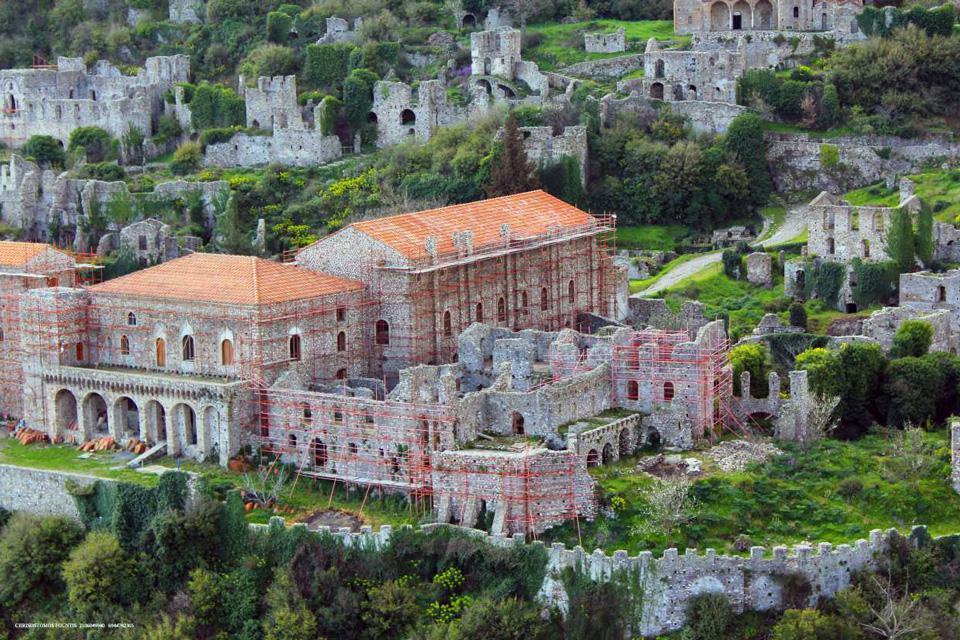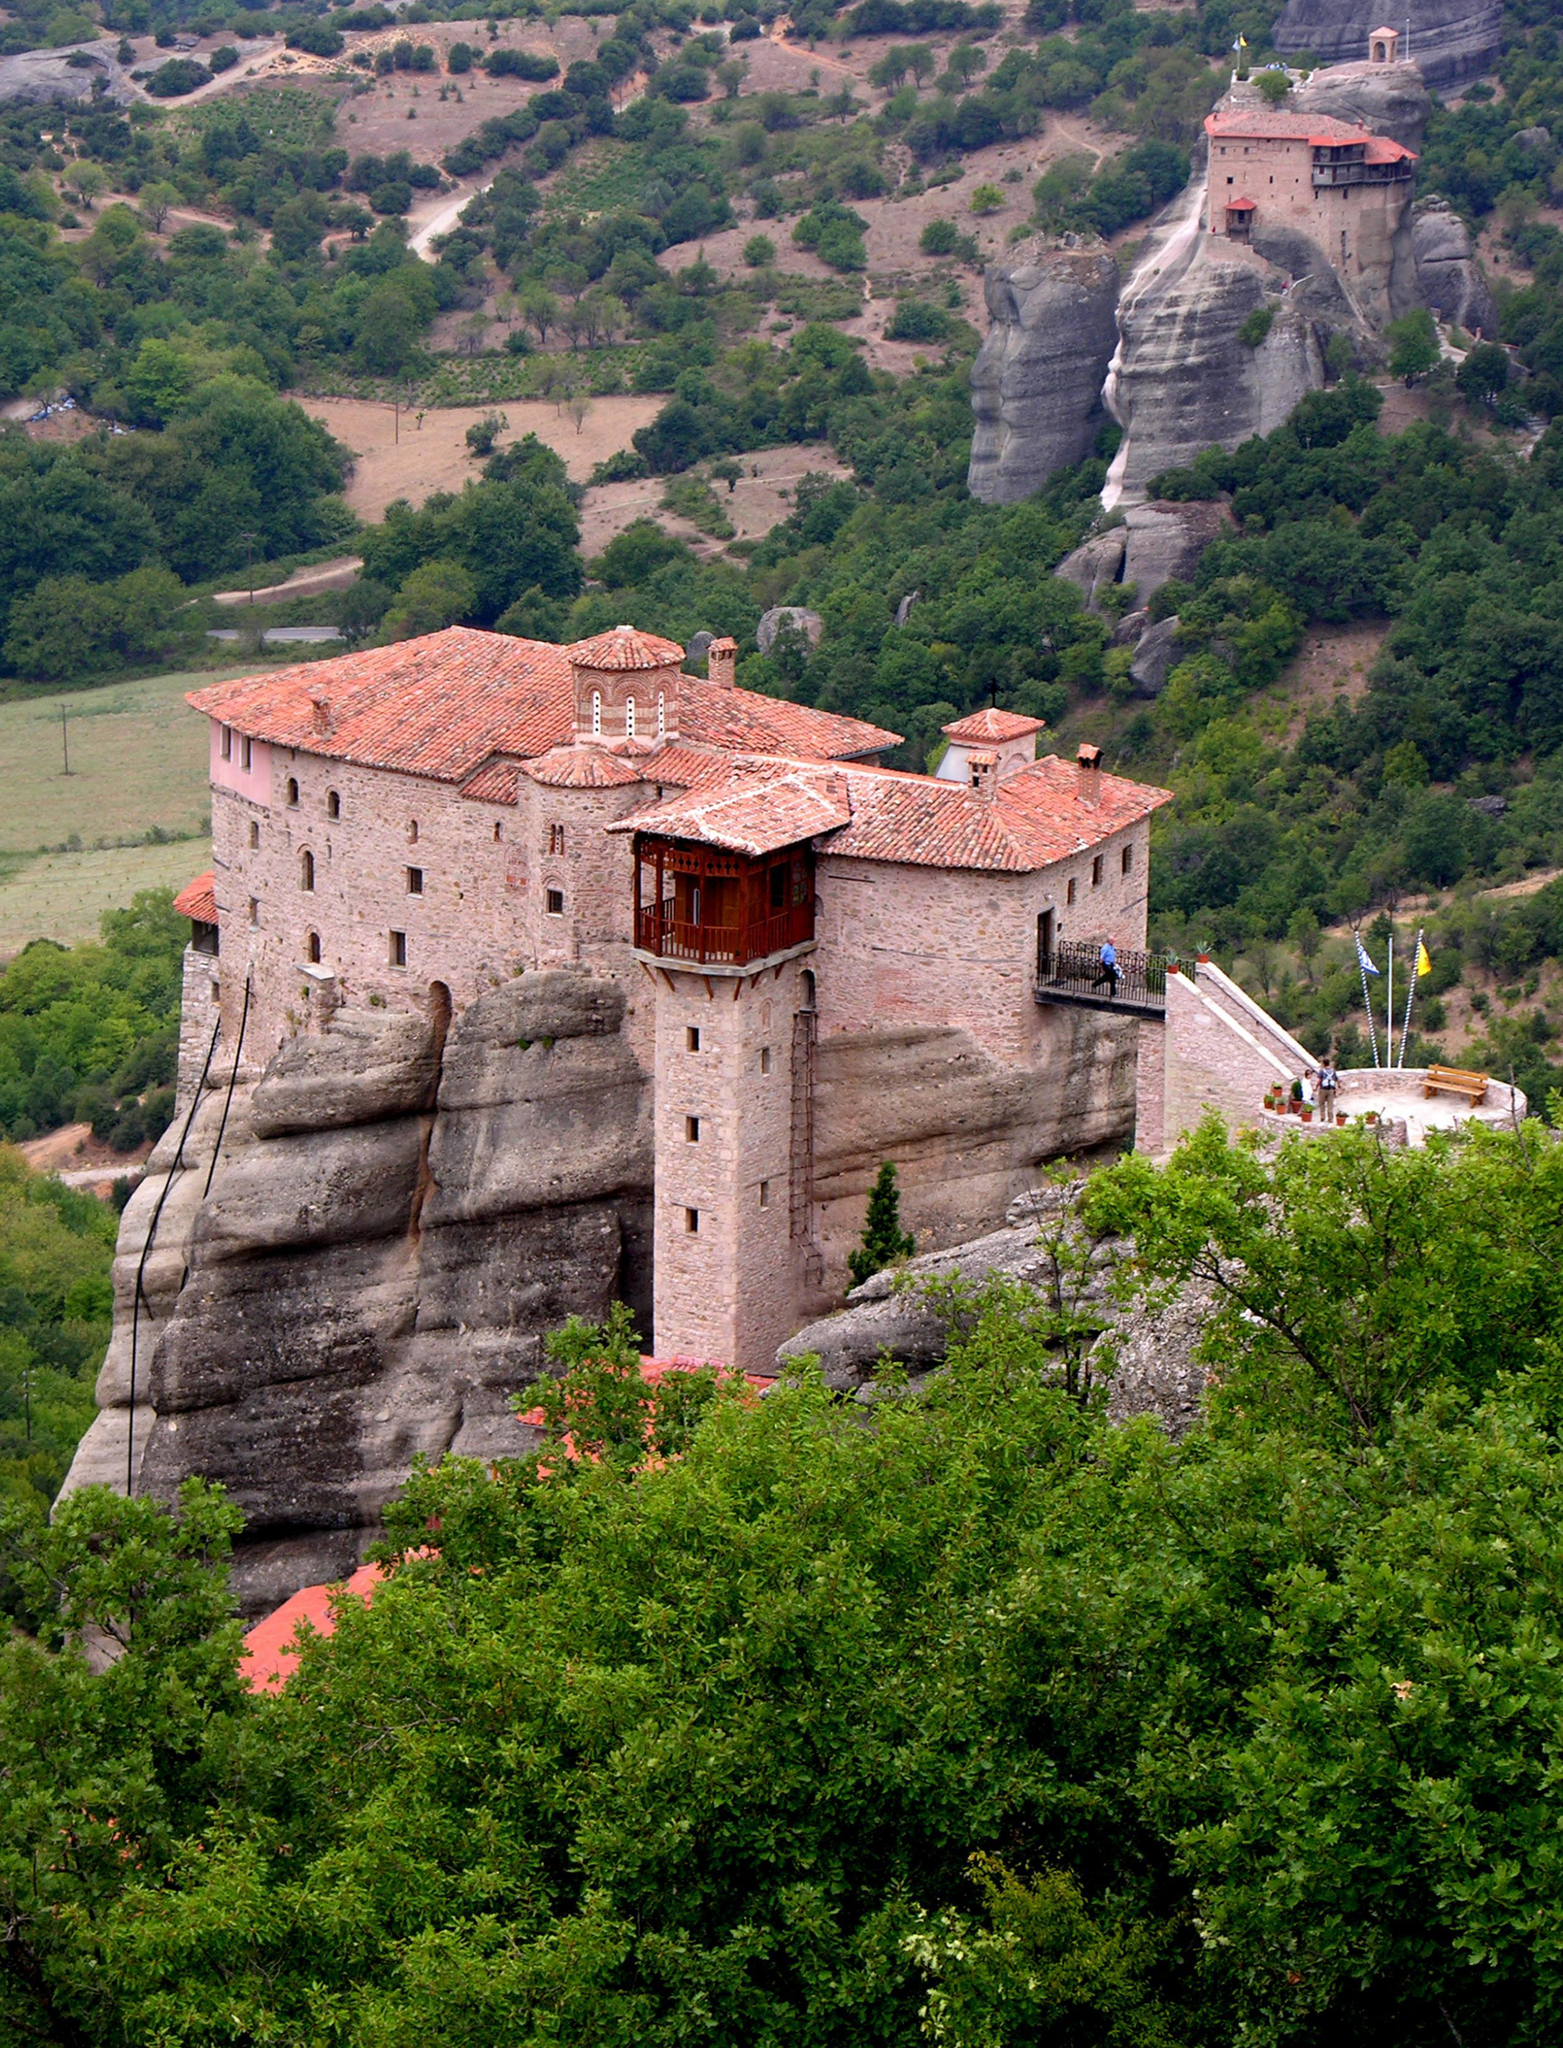The first image is the image on the left, the second image is the image on the right. For the images displayed, is the sentence "There is a wall surrounding some buildings." factually correct? Answer yes or no. Yes. 